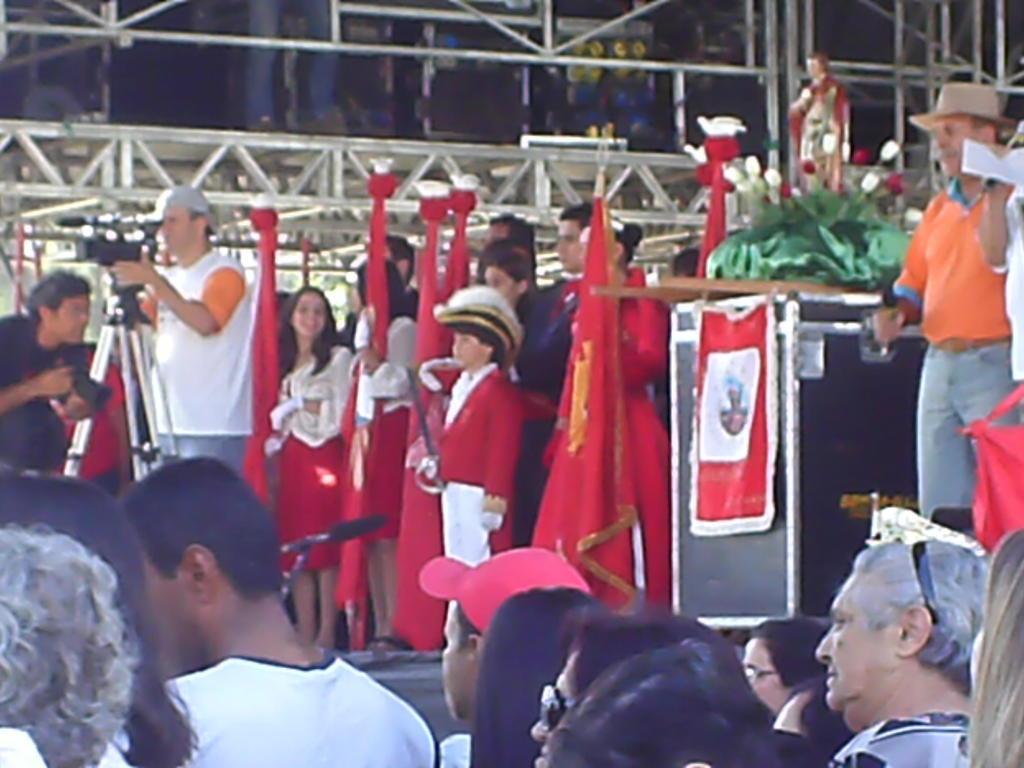How would you summarize this image in a sentence or two? In this image we can see people. On the right there is a board. On the left we can see a man holding a camera and there is a stand. In the background we can see railings and there are flags. 